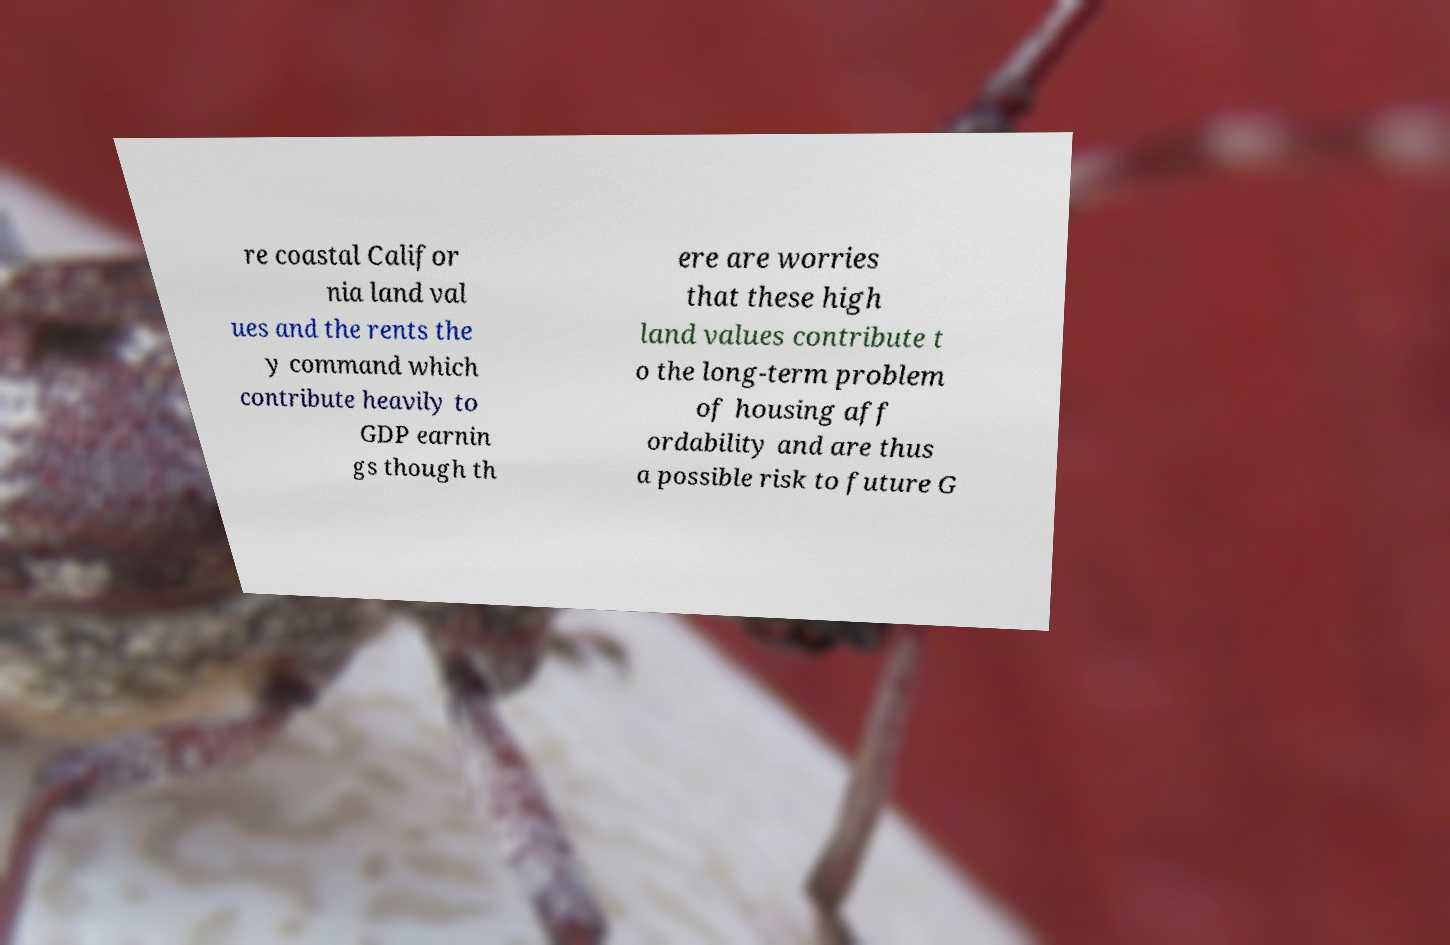Can you accurately transcribe the text from the provided image for me? re coastal Califor nia land val ues and the rents the y command which contribute heavily to GDP earnin gs though th ere are worries that these high land values contribute t o the long-term problem of housing aff ordability and are thus a possible risk to future G 